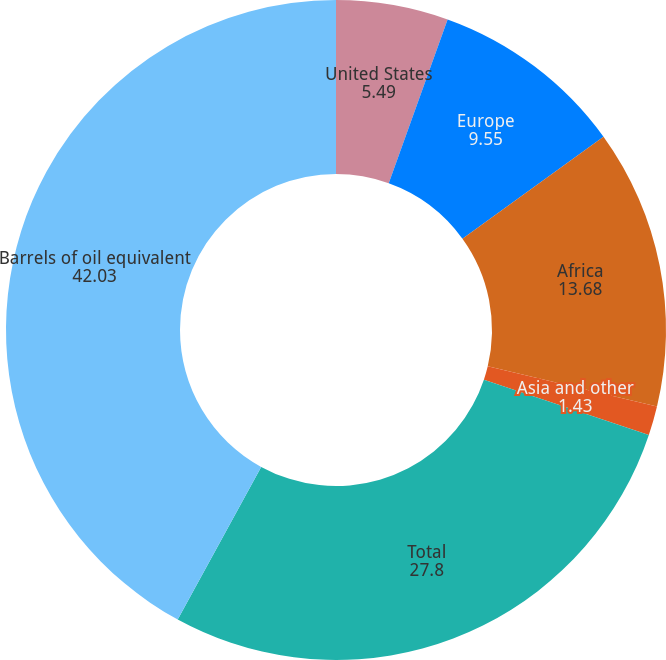Convert chart to OTSL. <chart><loc_0><loc_0><loc_500><loc_500><pie_chart><fcel>United States<fcel>Europe<fcel>Africa<fcel>Asia and other<fcel>Total<fcel>Barrels of oil equivalent<nl><fcel>5.49%<fcel>9.55%<fcel>13.68%<fcel>1.43%<fcel>27.8%<fcel>42.03%<nl></chart> 